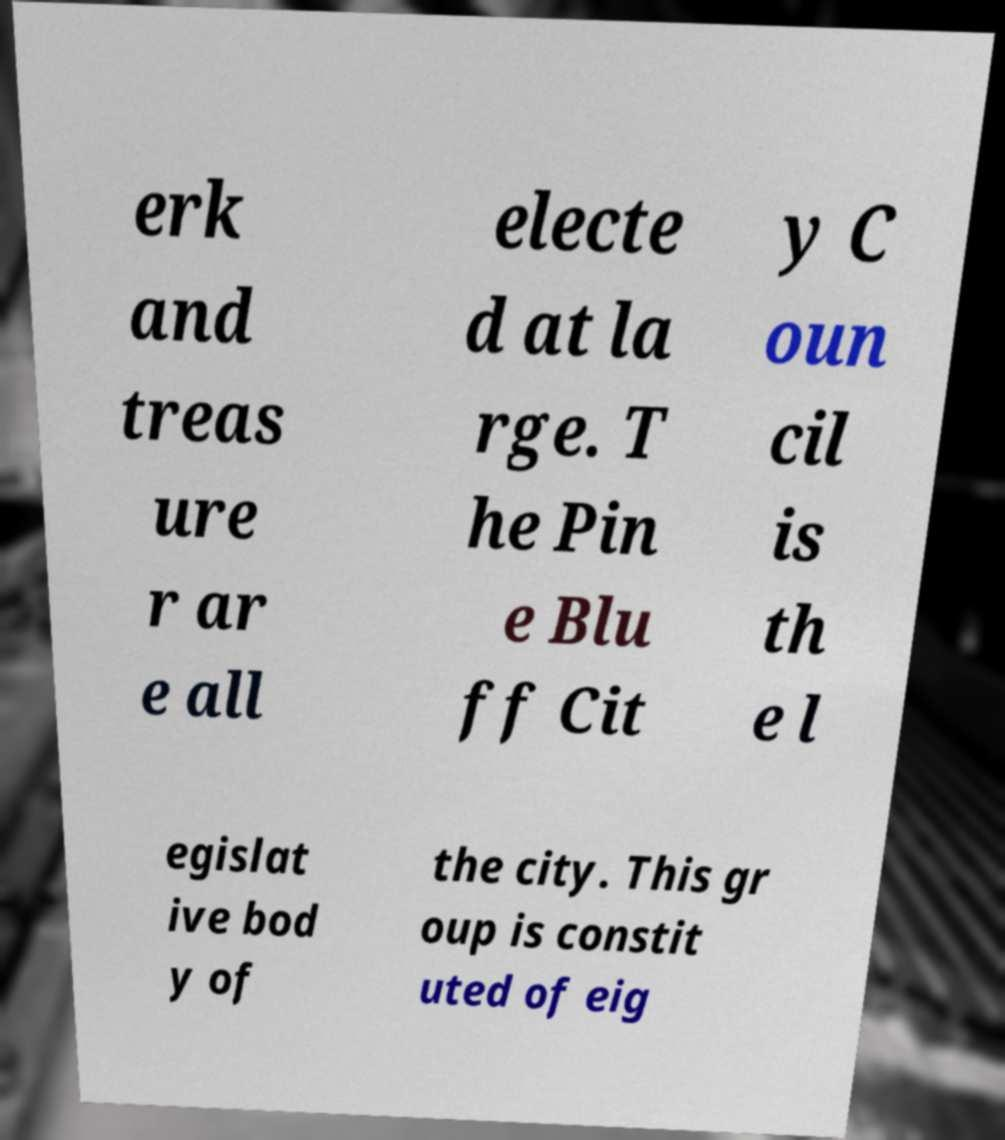Can you read and provide the text displayed in the image?This photo seems to have some interesting text. Can you extract and type it out for me? erk and treas ure r ar e all electe d at la rge. T he Pin e Blu ff Cit y C oun cil is th e l egislat ive bod y of the city. This gr oup is constit uted of eig 